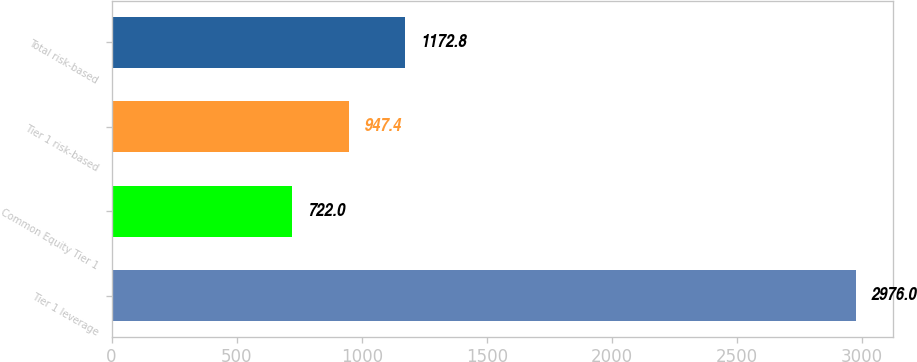Convert chart. <chart><loc_0><loc_0><loc_500><loc_500><bar_chart><fcel>Tier 1 leverage<fcel>Common Equity Tier 1<fcel>Tier 1 risk-based<fcel>Total risk-based<nl><fcel>2976<fcel>722<fcel>947.4<fcel>1172.8<nl></chart> 